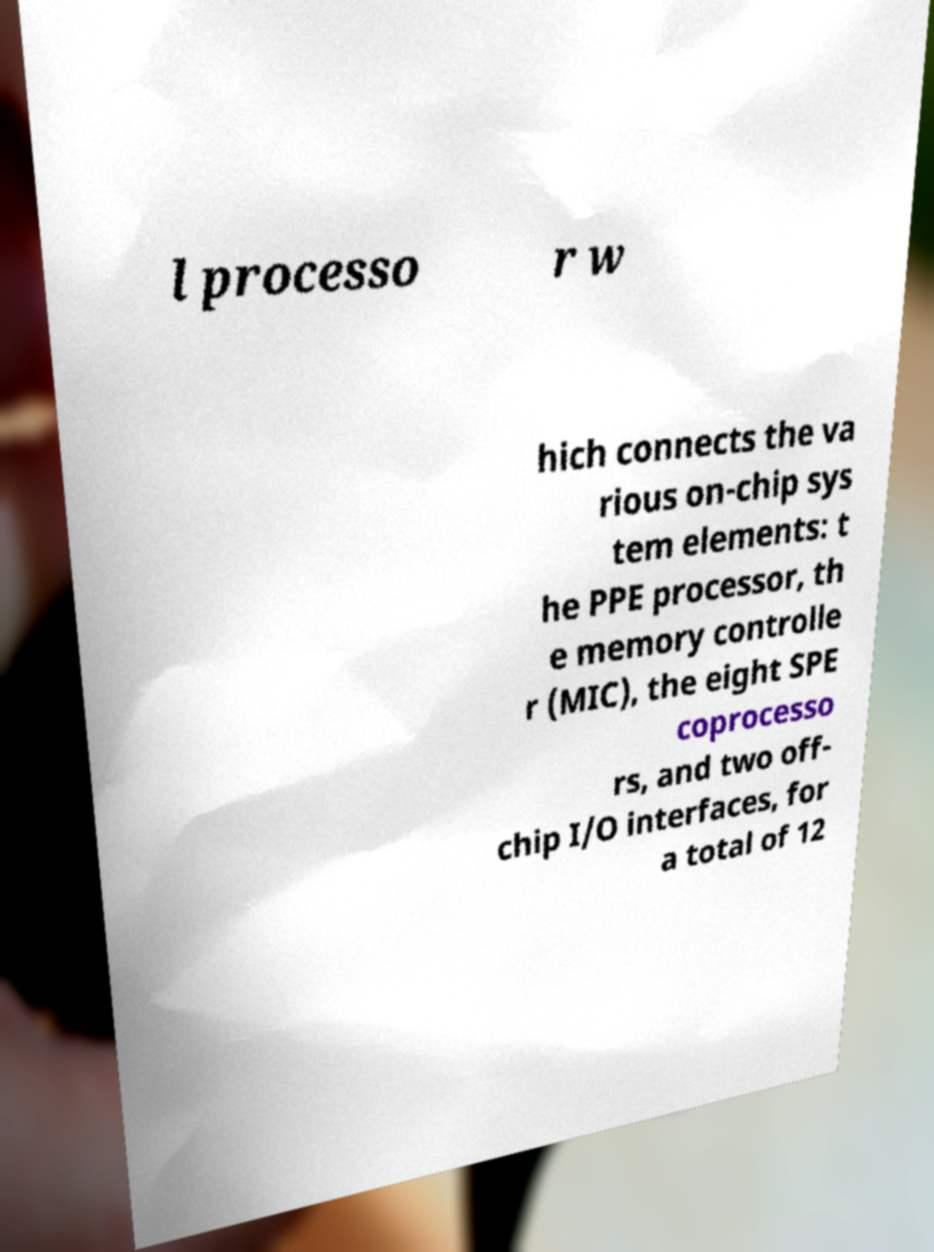Could you extract and type out the text from this image? l processo r w hich connects the va rious on-chip sys tem elements: t he PPE processor, th e memory controlle r (MIC), the eight SPE coprocesso rs, and two off- chip I/O interfaces, for a total of 12 